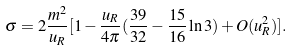<formula> <loc_0><loc_0><loc_500><loc_500>\sigma = 2 \frac { m ^ { 2 } } { u _ { R } } [ 1 - \frac { u _ { R } } { 4 \pi } ( \frac { 3 9 } { 3 2 } - \frac { 1 5 } { 1 6 } \ln 3 ) + O ( u _ { R } ^ { 2 } ) ] .</formula> 